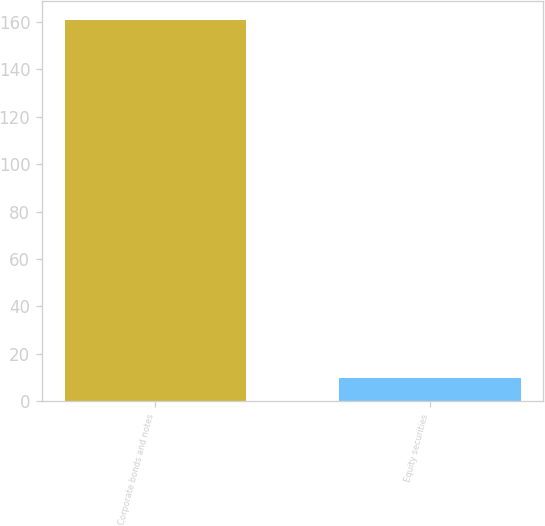Convert chart. <chart><loc_0><loc_0><loc_500><loc_500><bar_chart><fcel>Corporate bonds and notes<fcel>Equity securities<nl><fcel>161<fcel>10<nl></chart> 